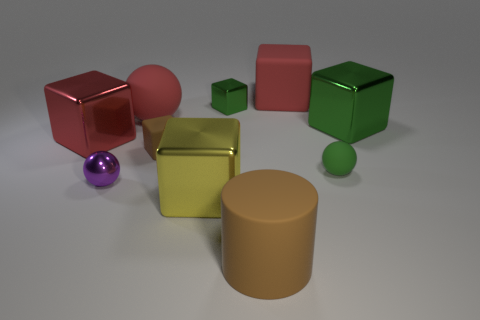What is the color of the tiny cube that is made of the same material as the big brown cylinder?
Offer a terse response. Brown. How many shiny things are small brown cubes or tiny green objects?
Make the answer very short. 1. Does the small purple thing have the same material as the large brown object?
Your response must be concise. No. There is a red rubber thing left of the large yellow block; what shape is it?
Your response must be concise. Sphere. Are there any red blocks behind the tiny ball on the right side of the tiny matte cube?
Offer a very short reply. Yes. Are there any green objects that have the same size as the red rubber sphere?
Provide a succinct answer. Yes. Is the color of the matte sphere behind the tiny green ball the same as the shiny ball?
Keep it short and to the point. No. What is the size of the purple metallic sphere?
Your answer should be very brief. Small. There is a rubber sphere on the right side of the big red cube on the right side of the big rubber cylinder; how big is it?
Keep it short and to the point. Small. How many cylinders are the same color as the metallic ball?
Make the answer very short. 0. 